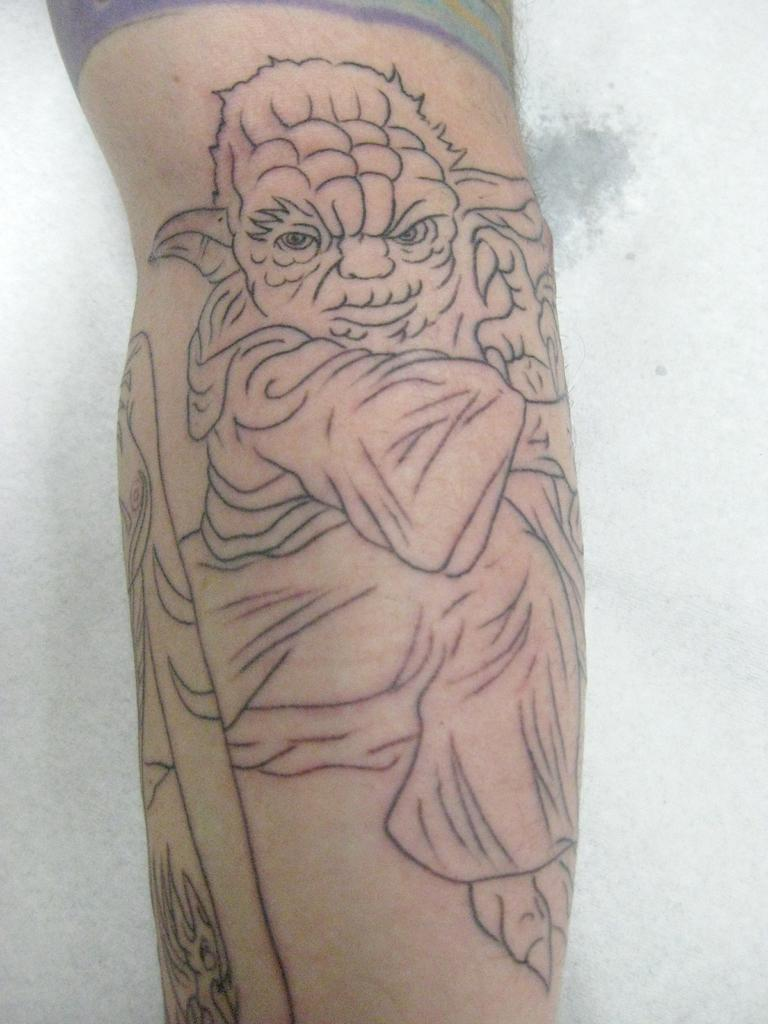What is visible on the person's hand in the image? There is a tattoo on a person's hand in the image. What color is the background of the image? The background of the image is white. What type of minister is standing near the beam in the image? There is no minister or beam present in the image; it only features a tattoo on a person's hand and a white background. 